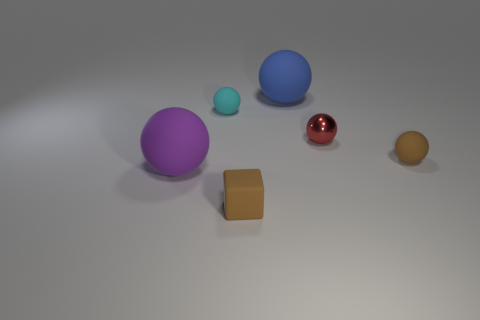What is the size of the matte ball that is the same color as the small rubber block?
Your answer should be compact. Small. How many other things are the same color as the small shiny object?
Keep it short and to the point. 0. Is the number of tiny cyan spheres in front of the cyan ball less than the number of small yellow balls?
Give a very brief answer. No. Is there a red metallic object that has the same size as the blue ball?
Keep it short and to the point. No. There is a matte block; is its color the same as the small matte ball that is in front of the cyan object?
Provide a short and direct response. Yes. How many large objects are behind the big matte thing in front of the large blue matte sphere?
Give a very brief answer. 1. There is a big rubber sphere that is in front of the tiny matte ball in front of the small cyan matte ball; what color is it?
Your answer should be very brief. Purple. There is a thing that is in front of the brown ball and to the left of the tiny brown matte block; what material is it?
Make the answer very short. Rubber. Is there another big object that has the same shape as the large purple thing?
Your response must be concise. Yes. There is a large thing that is left of the small cyan thing; does it have the same shape as the metal object?
Provide a succinct answer. Yes. 